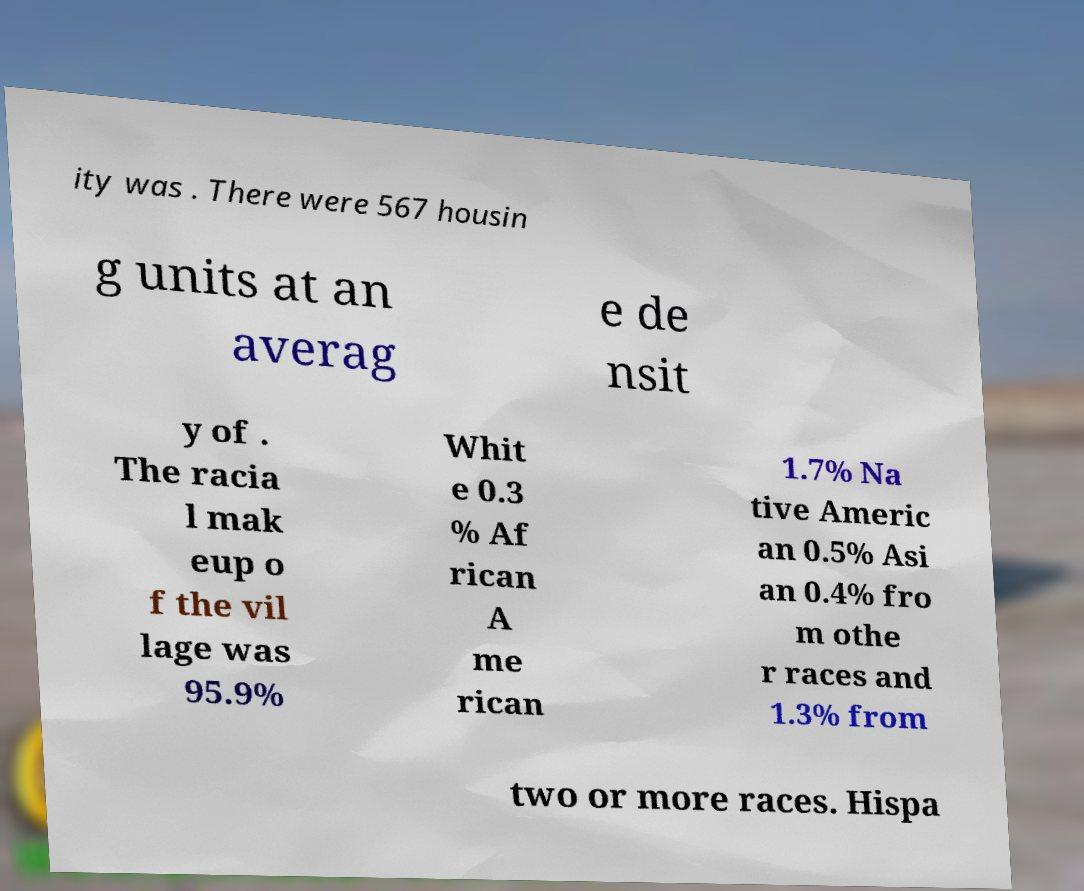I need the written content from this picture converted into text. Can you do that? ity was . There were 567 housin g units at an averag e de nsit y of . The racia l mak eup o f the vil lage was 95.9% Whit e 0.3 % Af rican A me rican 1.7% Na tive Americ an 0.5% Asi an 0.4% fro m othe r races and 1.3% from two or more races. Hispa 